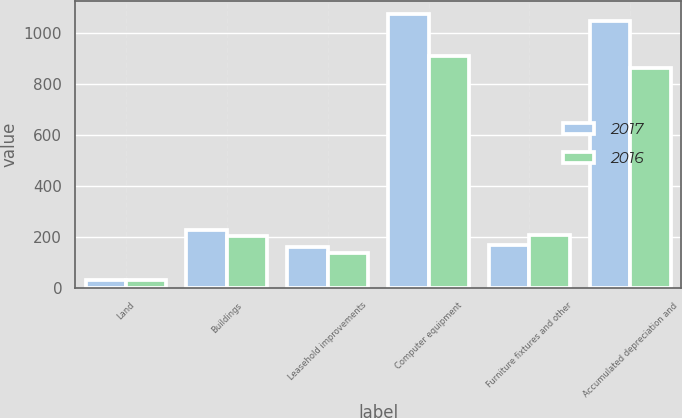Convert chart to OTSL. <chart><loc_0><loc_0><loc_500><loc_500><stacked_bar_chart><ecel><fcel>Land<fcel>Buildings<fcel>Leasehold improvements<fcel>Computer equipment<fcel>Furniture fixtures and other<fcel>Accumulated depreciation and<nl><fcel>2017<fcel>31<fcel>228<fcel>158<fcel>1073<fcel>167<fcel>1047<nl><fcel>2016<fcel>31<fcel>204<fcel>137<fcel>909<fcel>207<fcel>862<nl></chart> 